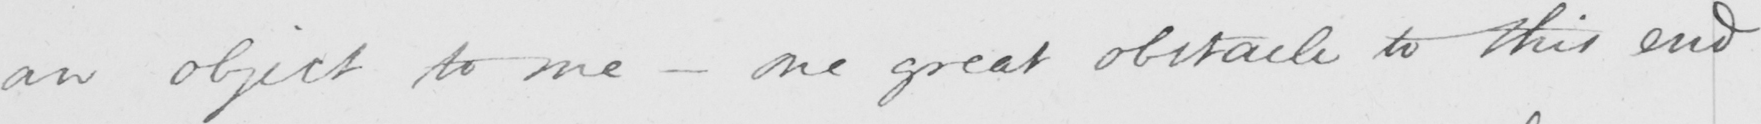What does this handwritten line say? an object to me  _  one great obstacle to this end 